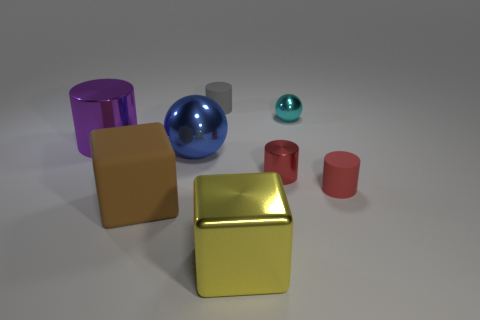Subtract all red shiny cylinders. How many cylinders are left? 3 Subtract all cyan spheres. How many red cylinders are left? 2 Subtract 1 cylinders. How many cylinders are left? 3 Subtract all gray cylinders. How many cylinders are left? 3 Add 1 small green shiny cubes. How many objects exist? 9 Subtract all cyan cylinders. Subtract all purple blocks. How many cylinders are left? 4 Subtract all blue objects. Subtract all tiny metal things. How many objects are left? 5 Add 3 large yellow things. How many large yellow things are left? 4 Add 3 big yellow metallic cubes. How many big yellow metallic cubes exist? 4 Subtract 0 yellow cylinders. How many objects are left? 8 